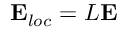<formula> <loc_0><loc_0><loc_500><loc_500>{ E } _ { l o c } = L { E }</formula> 